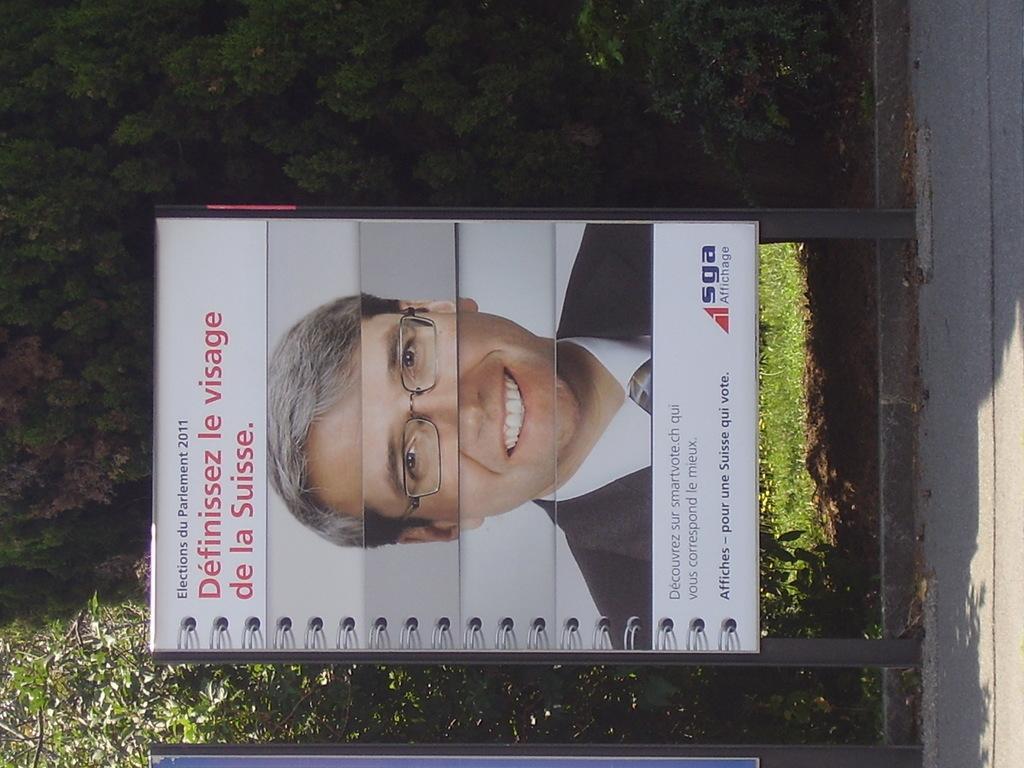In one or two sentences, can you explain what this image depicts? In this image we can see a board with image and text and trees in the background. 